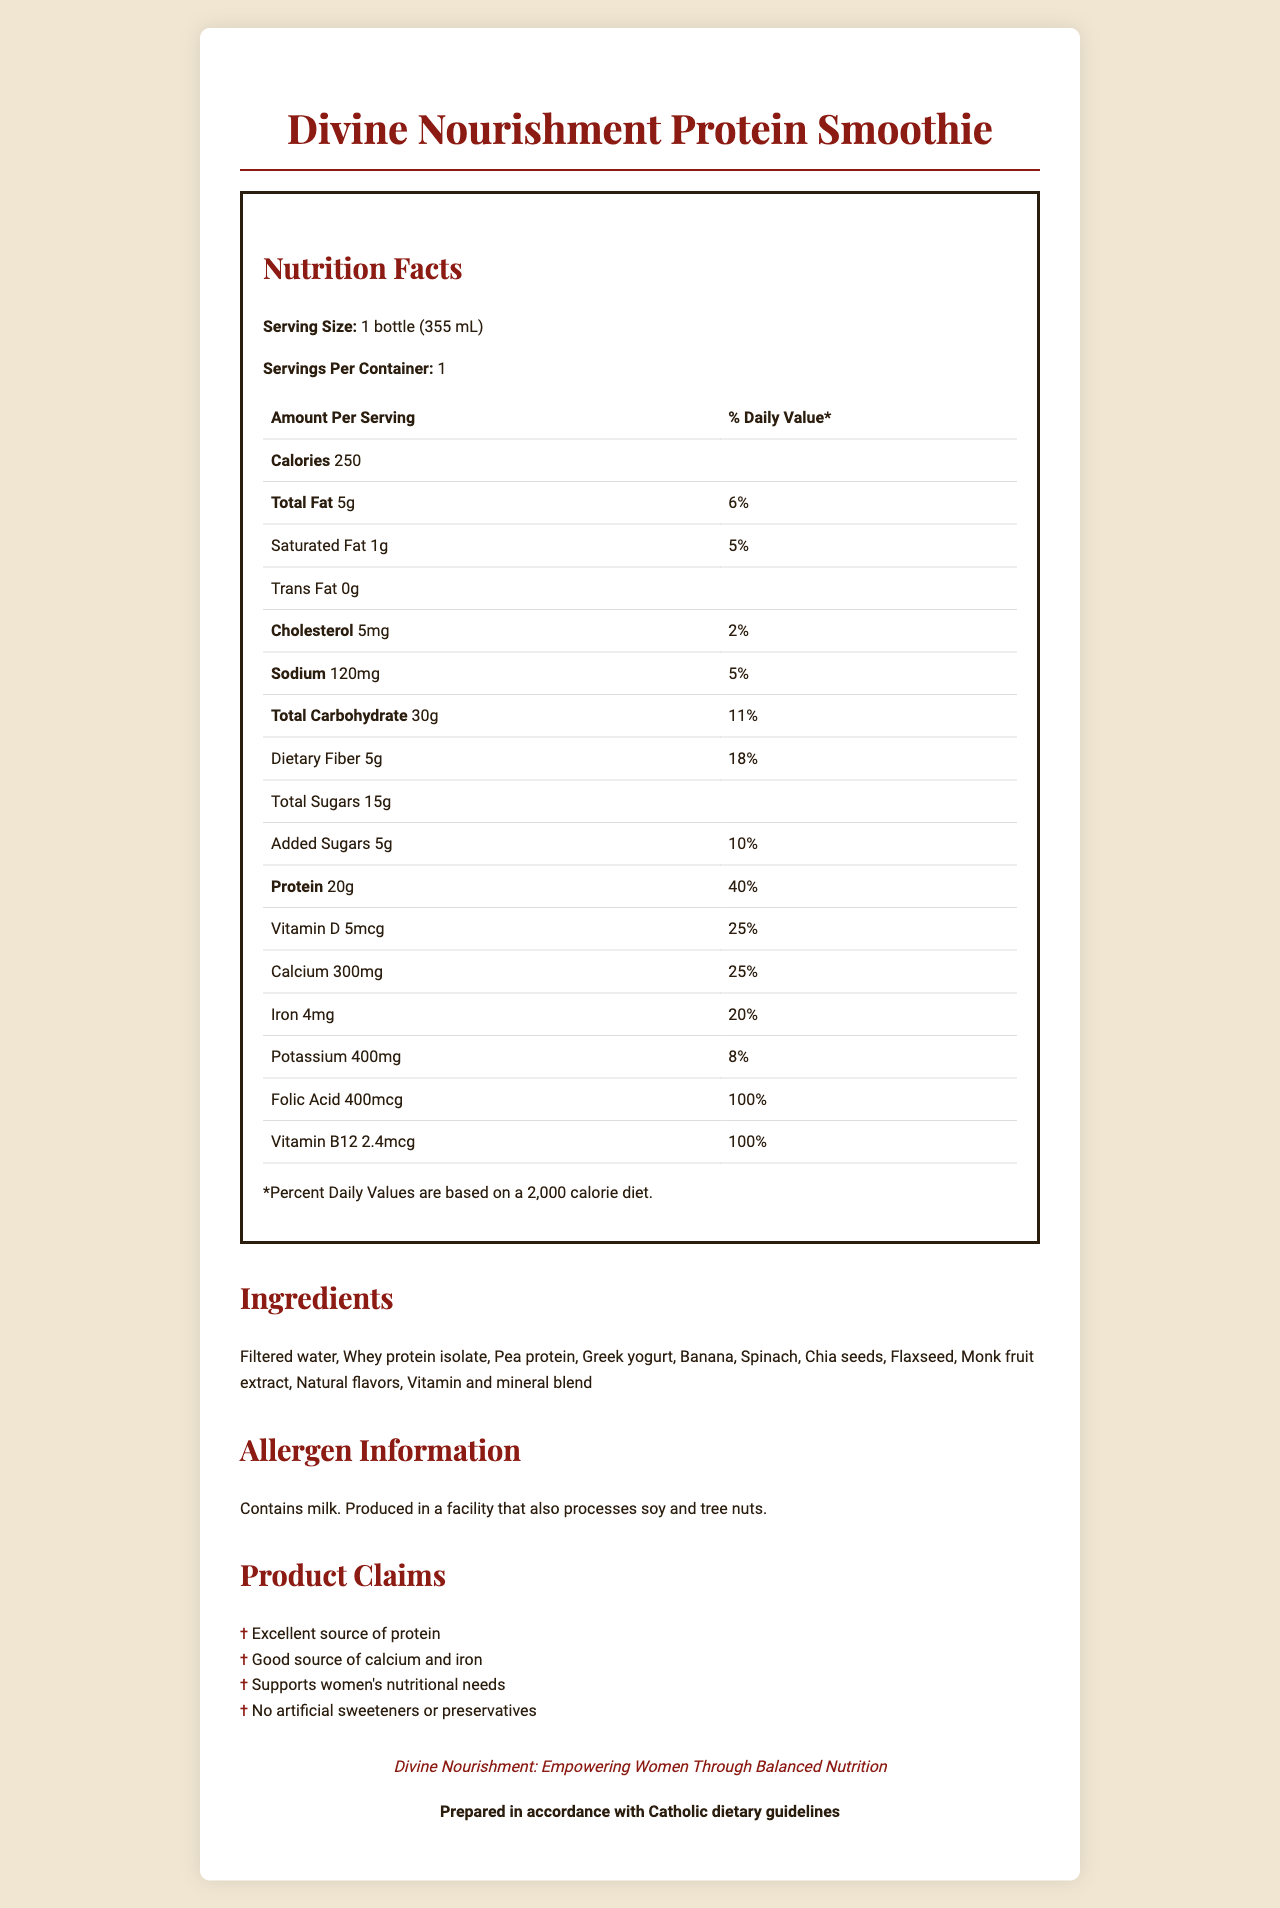what is the serving size? The Nutrition Facts section indicates that the serving size is 1 bottle (355 mL).
Answer: 1 bottle (355 mL) how many calories are in one serving? The document states that the smoothie contains 250 calories per serving.
Answer: 250 what percentage of the daily value is the dietary fiber? The Nutrition Facts label shows that the dietary fiber is 5g, which is 18% of the daily value.
Answer: 18% what are the main protein sources? The ingredients list includes Whey protein isolate, Pea protein, and Greek yogurt as main sources of protein.
Answer: Whey protein isolate, Pea protein, Greek yogurt what amount of sodium is in one serving? The sodium content per serving is listed as 120 mg in the Nutrition Facts section.
Answer: 120mg which nutrient has the highest percentage of daily value? A. Vitamin D B. Calcium C. Folic Acid D. Iron According to the Nutrition Facts, Folic Acid has a daily value of 100%, which is the highest among the nutrients listed.
Answer: C. Folic Acid which of the following is a claim made by the product? A. Contains artificial sweeteners B. Supports women's nutritional needs C. Contains tree nuts D. No protein The claim "Supports women's nutritional needs" is explicitly listed in the Product Claims section.
Answer: B. Supports women's nutritional needs is this product suitable for someone with a milk allergy? The allergen statement indicates that the product contains milk, making it unsuitable for someone with a milk allergy.
Answer: No describe the main purpose of this document. The document is designed to inform consumers about the nutritional content and benefits of the Divine Nourishment Protein Smoothie, highlighting how it meets various dietary needs and claims.
Answer: The document provides detailed nutritional information about the Divine Nourishment Protein Smoothie, including its ingredients, nutrient content, and various product claims to support women's nutritional needs. how many grams of added sugars are there in one serving? The Nutrition Facts section lists 5g of added sugars per serving.
Answer: 5g don’t the ingredients include any preservatives? The claim "No artificial sweeteners or preservatives" is stated in the Product Claims section, indicating the absence of preservatives.
Answer: No how much calcium is in the smoothie? The document specifies that there are 300 mg of calcium per serving.
Answer: 300mg what is the religious statement for this product? The religious statement at the end of the document specifies that the product is "Prepared in accordance with Catholic dietary guidelines".
Answer: Prepared in accordance with Catholic dietary guidelines does the product contain any amount of trans fat? The Nutrition Facts label shows that the amount of trans fat is 0g.
Answer: No what time of day should I consume this smoothie? The document does not provide any details or recommendations on the time of day for consuming the smoothie.
Answer: Not enough information 